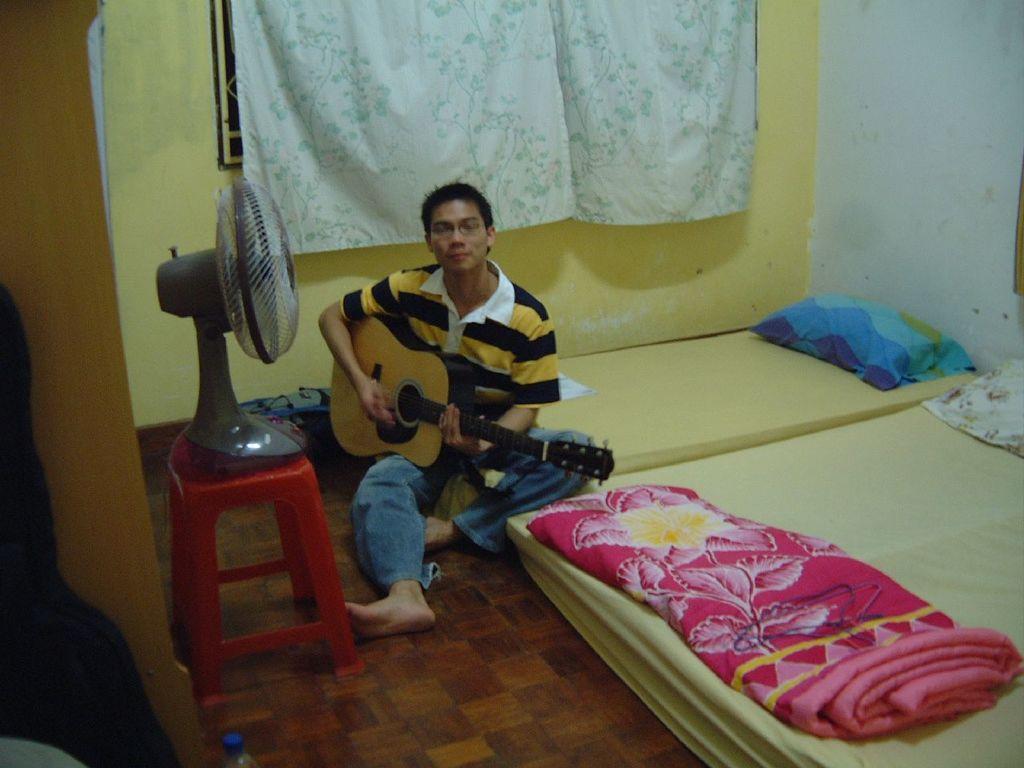In one or two sentences, can you explain what this image depicts? In this picture there is a person who is sitting on the quilt at the center of the image and there is a table fan at the left side of the image and a window at the center of the image, he is playing the guitar. 